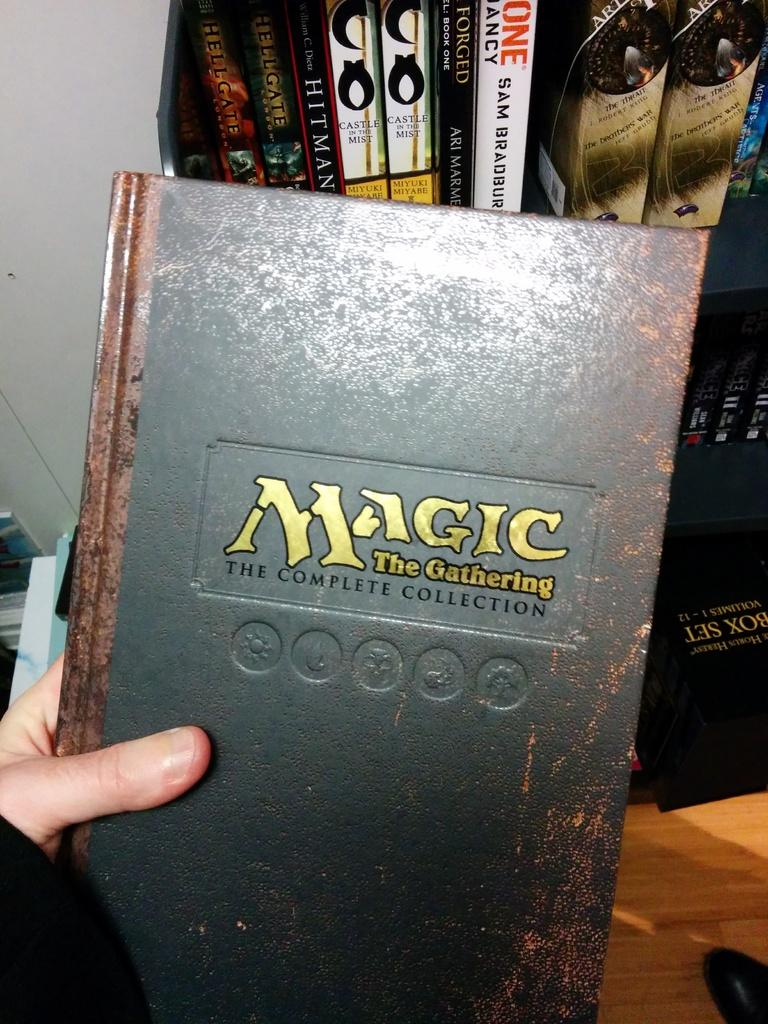<image>
Describe the image concisely. A magic book is black with gold lettering and is called The Gathering. 